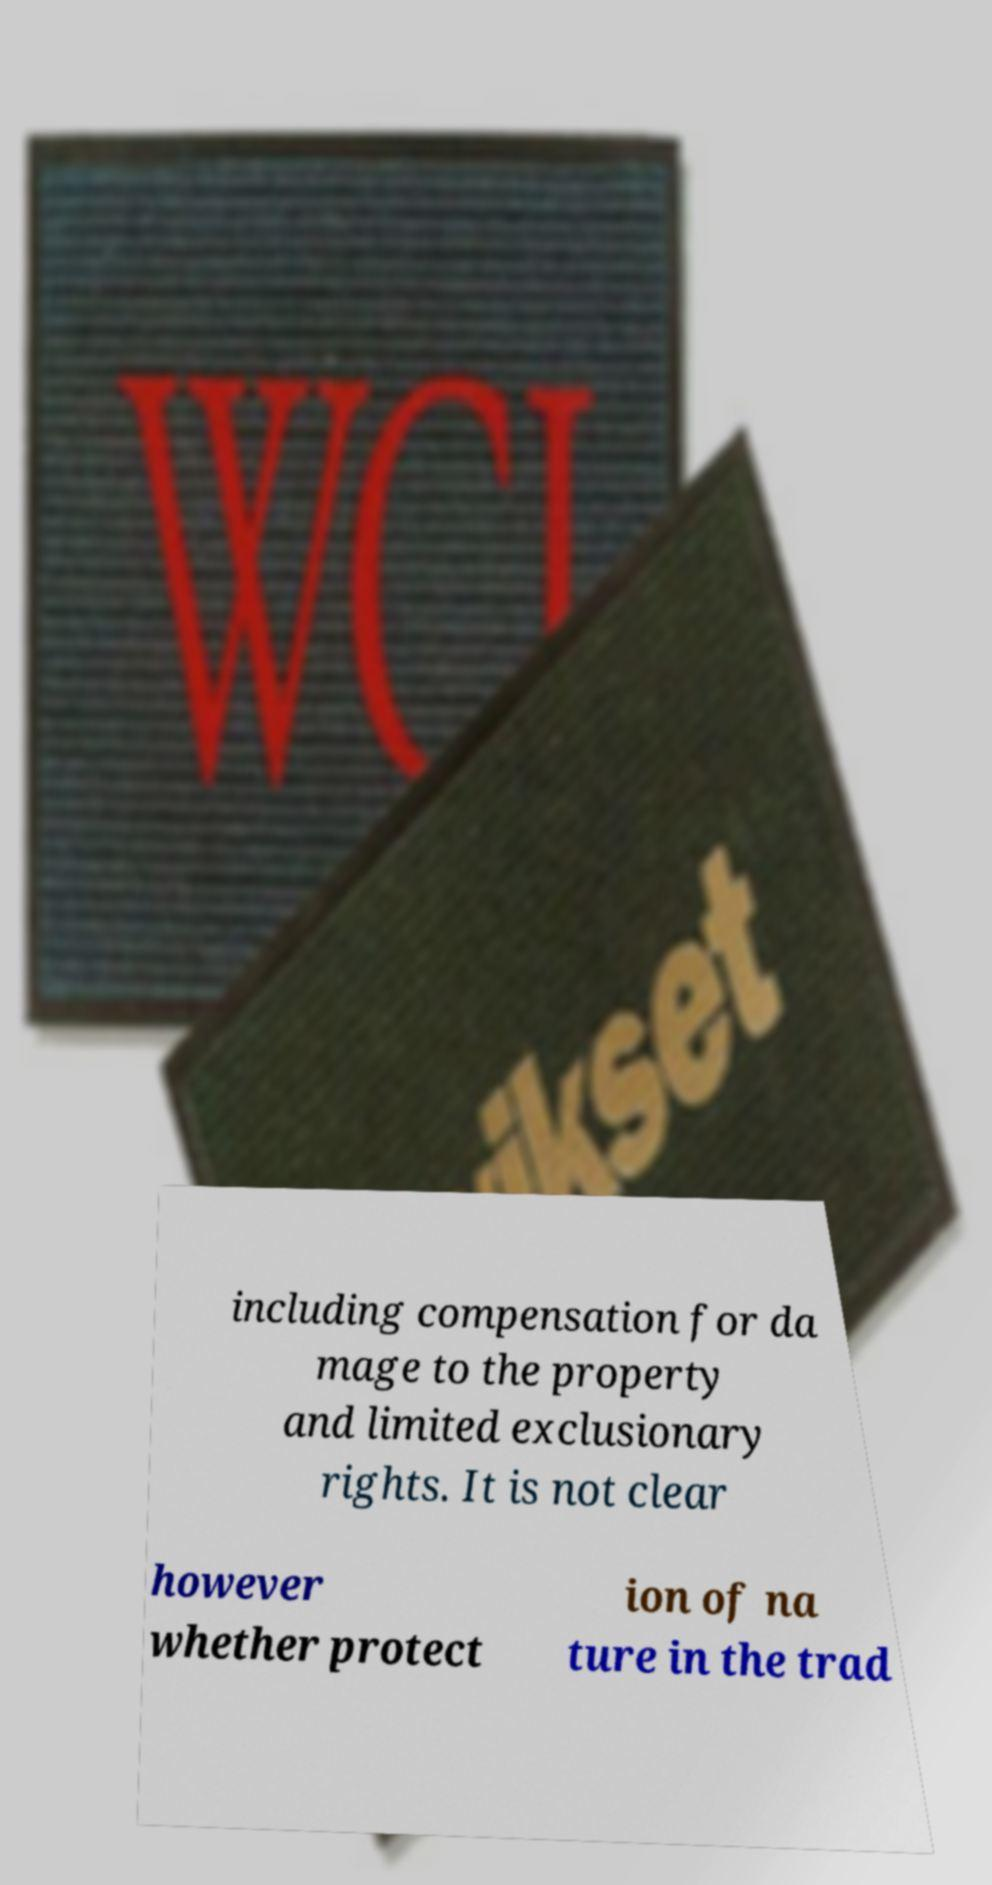Can you read and provide the text displayed in the image?This photo seems to have some interesting text. Can you extract and type it out for me? including compensation for da mage to the property and limited exclusionary rights. It is not clear however whether protect ion of na ture in the trad 